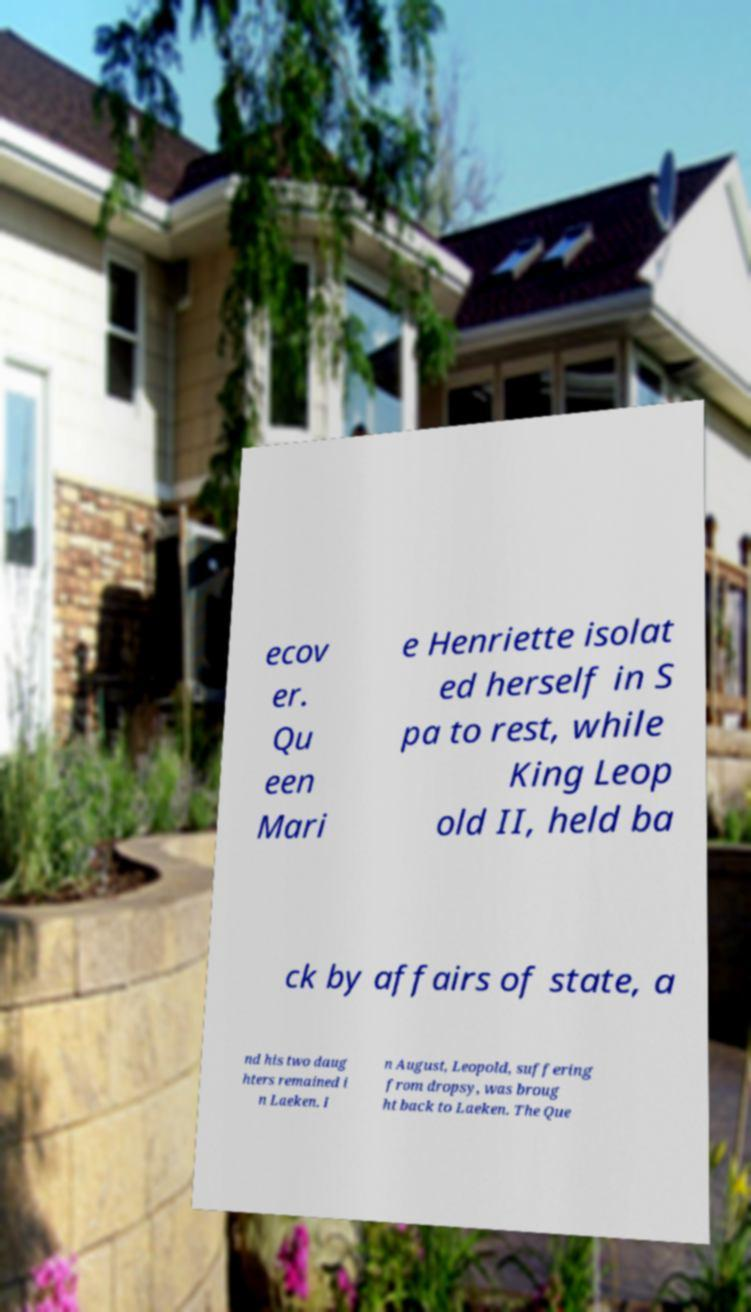There's text embedded in this image that I need extracted. Can you transcribe it verbatim? ecov er. Qu een Mari e Henriette isolat ed herself in S pa to rest, while King Leop old II, held ba ck by affairs of state, a nd his two daug hters remained i n Laeken. I n August, Leopold, suffering from dropsy, was broug ht back to Laeken. The Que 